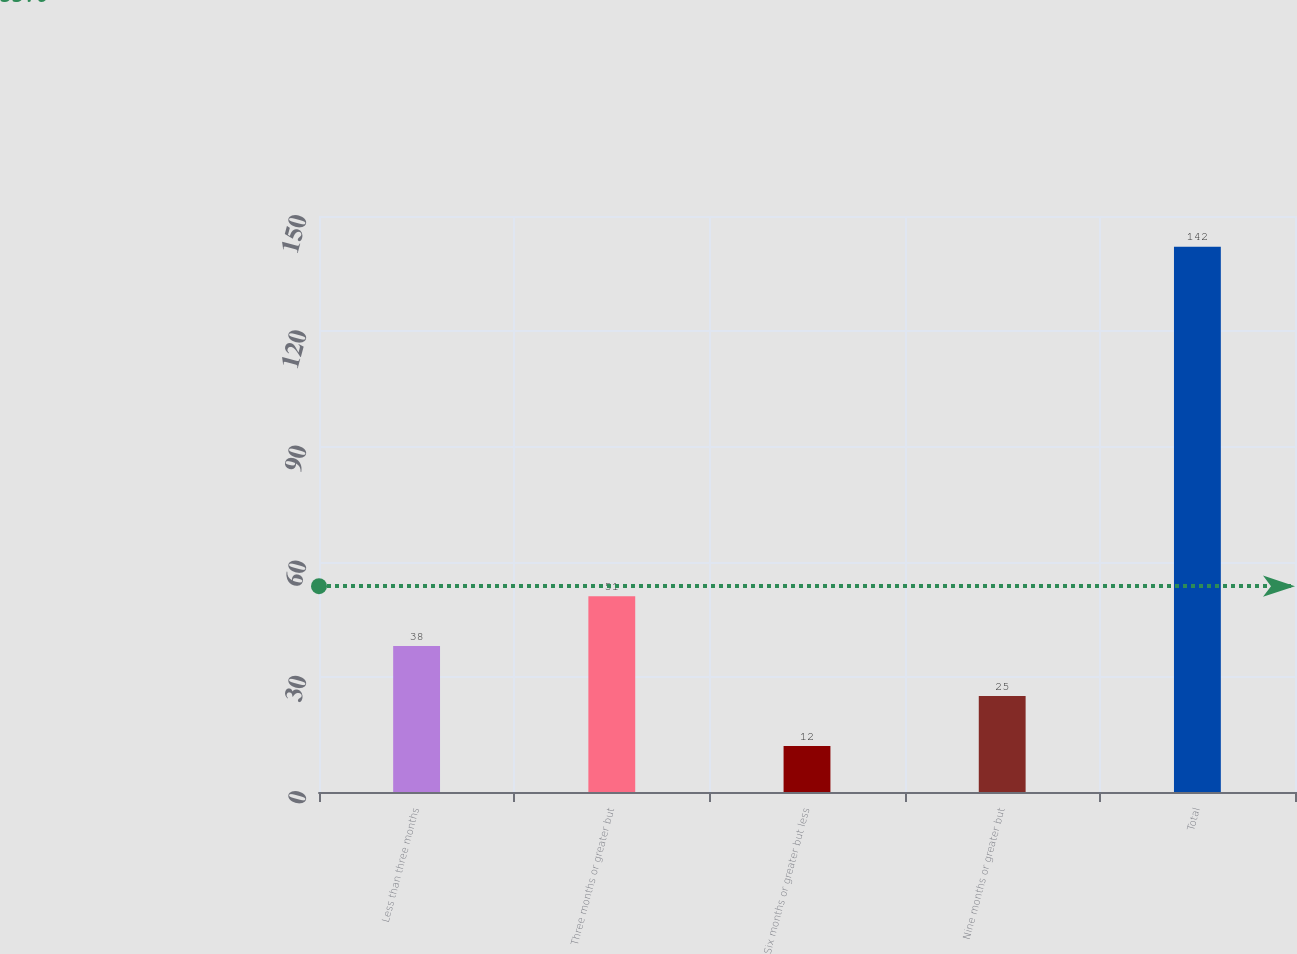Convert chart. <chart><loc_0><loc_0><loc_500><loc_500><bar_chart><fcel>Less than three months<fcel>Three months or greater but<fcel>Six months or greater but less<fcel>Nine months or greater but<fcel>Total<nl><fcel>38<fcel>51<fcel>12<fcel>25<fcel>142<nl></chart> 